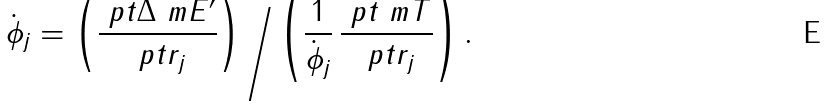Convert formula to latex. <formula><loc_0><loc_0><loc_500><loc_500>\dot { \phi } _ { j } = \left ( \frac { \ p t \Delta \ m E ^ { \prime } } { \ p t r _ { j } } \right ) \Big / \left ( \frac { 1 } { \dot { \phi } _ { j } } \, \frac { \ p t \ m T } { \ p t r _ { j } } \right ) .</formula> 